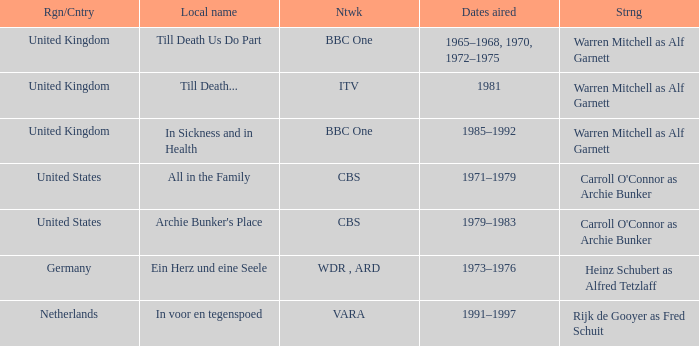Could you help me parse every detail presented in this table? {'header': ['Rgn/Cntry', 'Local name', 'Ntwk', 'Dates aired', 'Strng'], 'rows': [['United Kingdom', 'Till Death Us Do Part', 'BBC One', '1965–1968, 1970, 1972–1975', 'Warren Mitchell as Alf Garnett'], ['United Kingdom', 'Till Death...', 'ITV', '1981', 'Warren Mitchell as Alf Garnett'], ['United Kingdom', 'In Sickness and in Health', 'BBC One', '1985–1992', 'Warren Mitchell as Alf Garnett'], ['United States', 'All in the Family', 'CBS', '1971–1979', "Carroll O'Connor as Archie Bunker"], ['United States', "Archie Bunker's Place", 'CBS', '1979–1983', "Carroll O'Connor as Archie Bunker"], ['Germany', 'Ein Herz und eine Seele', 'WDR , ARD', '1973–1976', 'Heinz Schubert as Alfred Tetzlaff'], ['Netherlands', 'In voor en tegenspoed', 'VARA', '1991–1997', 'Rijk de Gooyer as Fred Schuit']]} What is the name of the network in the United Kingdom which aired in 1985–1992? BBC One. 